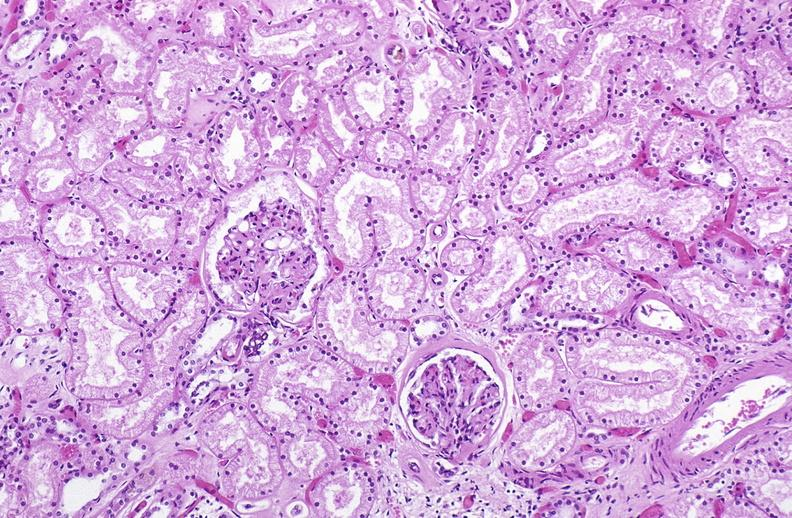does this image show atn acute tubular necrosis?
Answer the question using a single word or phrase. Yes 